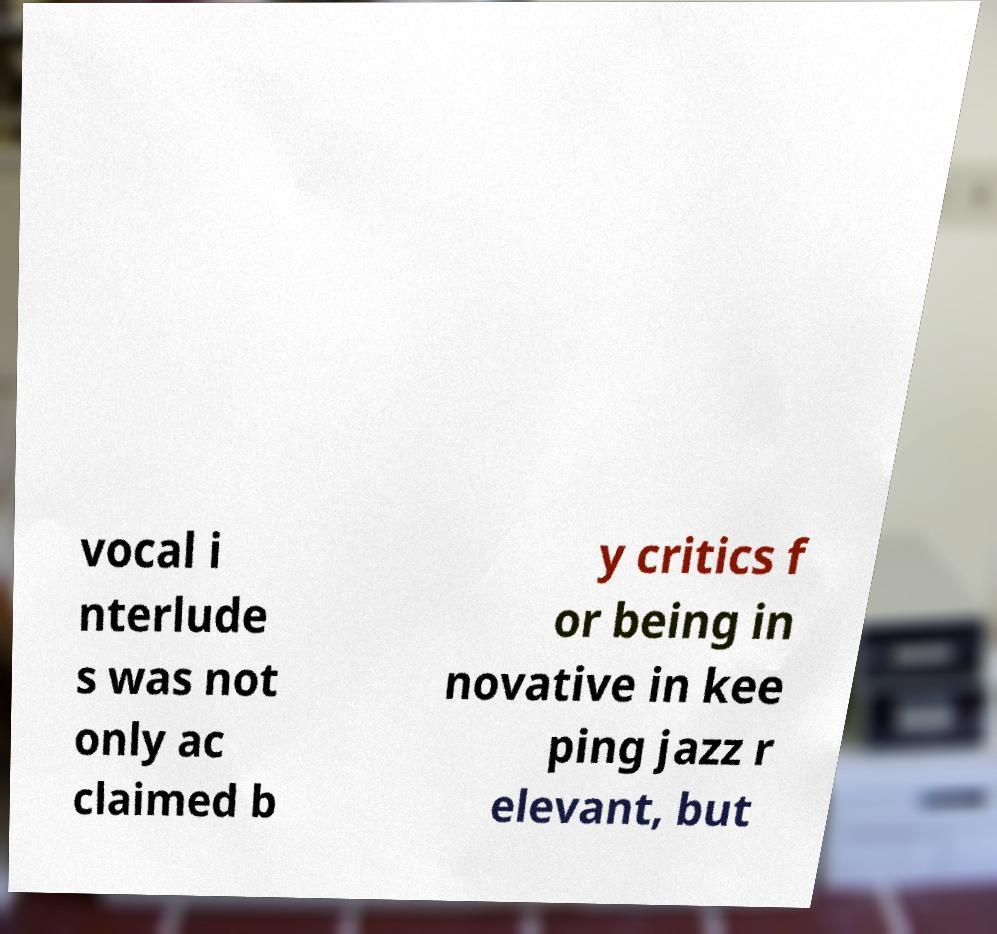There's text embedded in this image that I need extracted. Can you transcribe it verbatim? vocal i nterlude s was not only ac claimed b y critics f or being in novative in kee ping jazz r elevant, but 